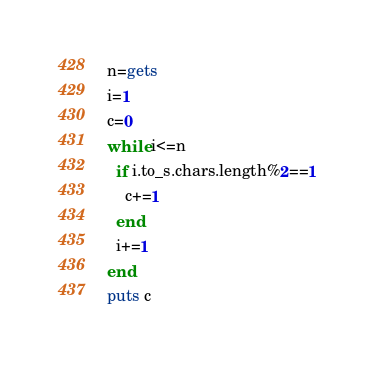Convert code to text. <code><loc_0><loc_0><loc_500><loc_500><_Ruby_>n=gets
i=1
c=0
while i<=n
  if i.to_s.chars.length%2==1
    c+=1
  end
  i+=1
end
puts c</code> 